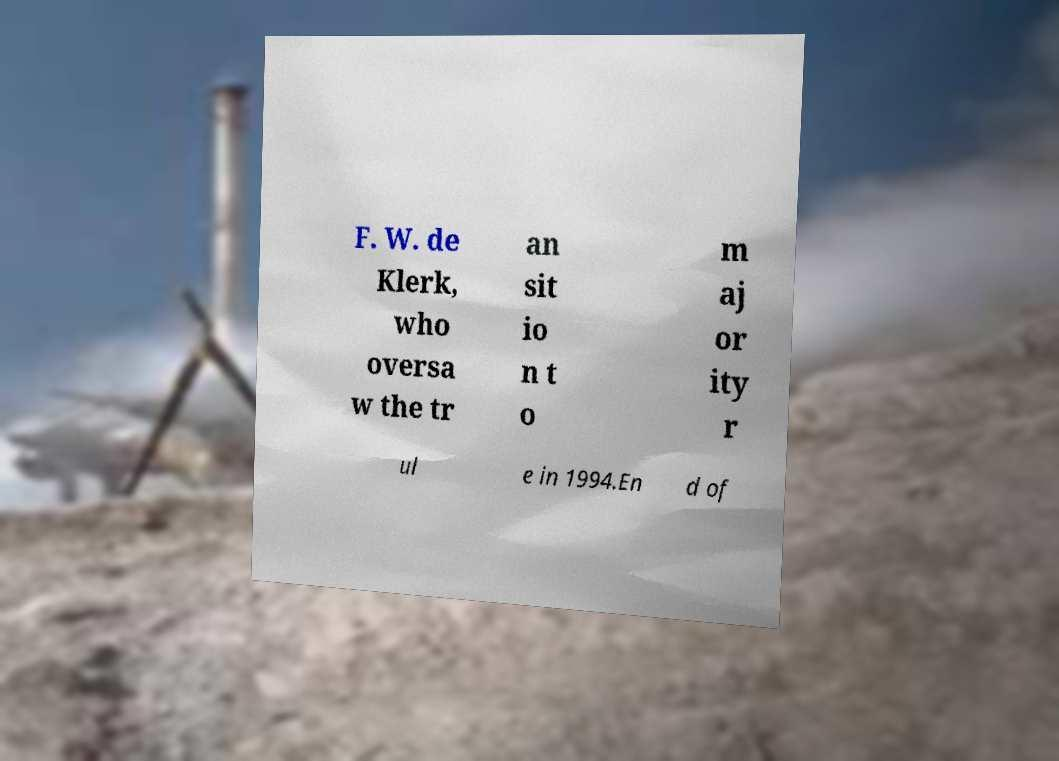Please read and relay the text visible in this image. What does it say? F. W. de Klerk, who oversa w the tr an sit io n t o m aj or ity r ul e in 1994.En d of 